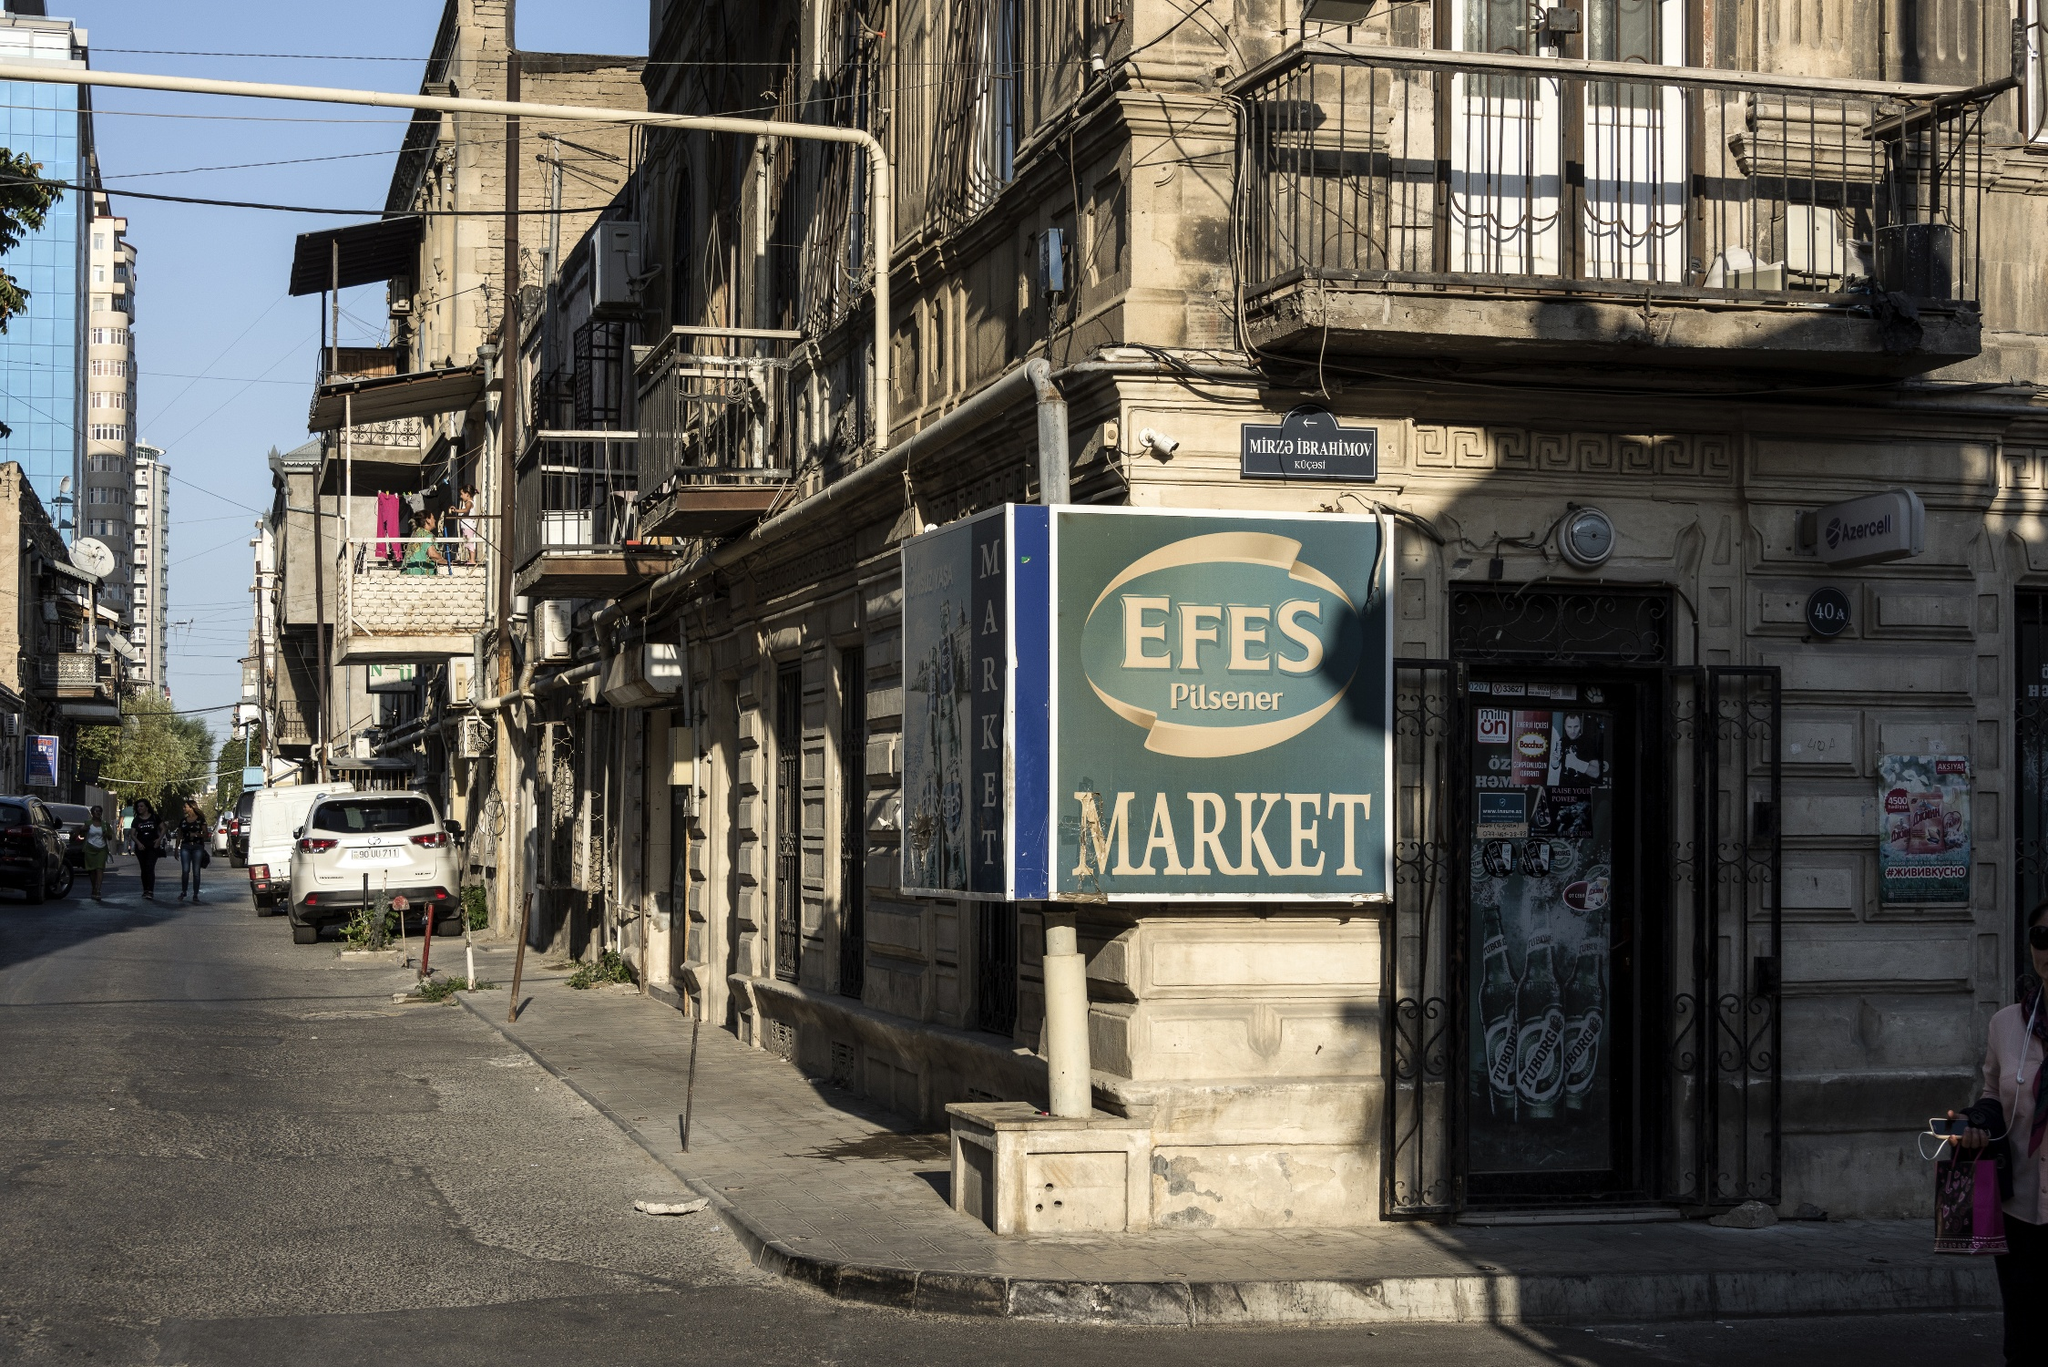Is there any indication of cultural or historical significance in the image? Yes, the image gives several indications of cultural and historical significance. The architecture of the buildings, with their classic European and Middle Eastern design elements, hints at Istanbul's rich cultural tapestry and its historical role as a crossroad of civilizations. The weathered facades suggest age and a wealth of stories embedded in the walls. The market named "EFES Pilsener" itself references an internationally known beer, suggesting a blend of local and global influences—a hallmark of Istanbul's unique cultural landscape. 